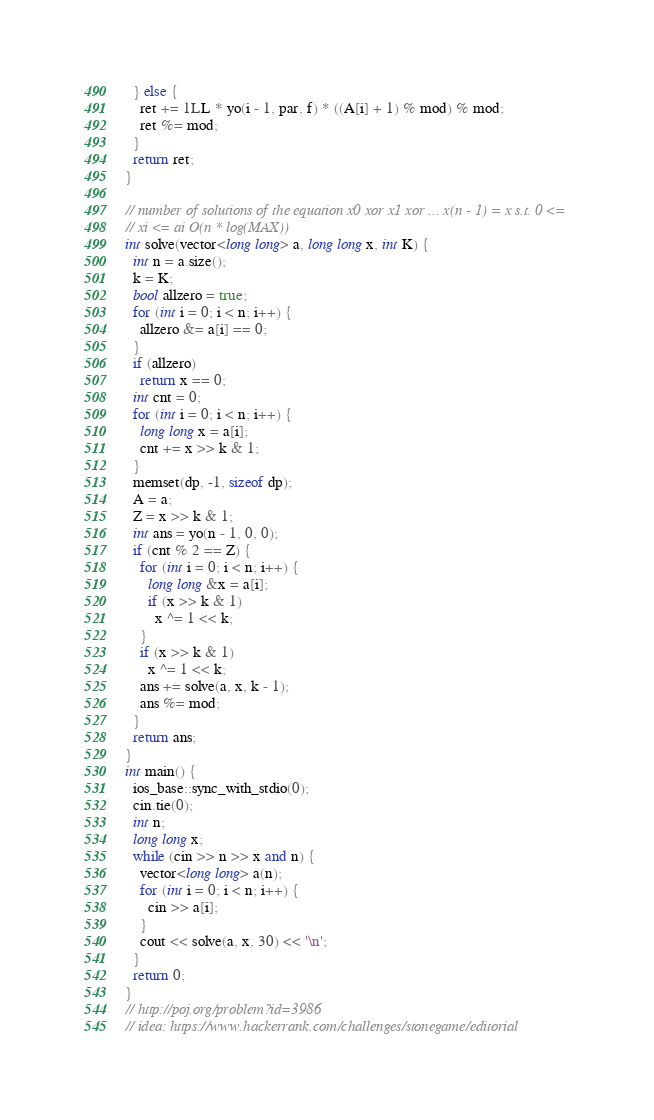<code> <loc_0><loc_0><loc_500><loc_500><_C++_>  } else {
    ret += 1LL * yo(i - 1, par, f) * ((A[i] + 1) % mod) % mod;
    ret %= mod;
  }
  return ret;
}

// number of solutions of the equation x0 xor x1 xor ... x(n - 1) = x s.t. 0 <=
// xi <= ai O(n * log(MAX))
int solve(vector<long long> a, long long x, int K) {
  int n = a.size();
  k = K;
  bool allzero = true;
  for (int i = 0; i < n; i++) {
    allzero &= a[i] == 0;
  }
  if (allzero)
    return x == 0;
  int cnt = 0;
  for (int i = 0; i < n; i++) {
    long long x = a[i];
    cnt += x >> k & 1;
  }
  memset(dp, -1, sizeof dp);
  A = a;
  Z = x >> k & 1;
  int ans = yo(n - 1, 0, 0);
  if (cnt % 2 == Z) {
    for (int i = 0; i < n; i++) {
      long long &x = a[i];
      if (x >> k & 1)
        x ^= 1 << k;
    }
    if (x >> k & 1)
      x ^= 1 << k;
    ans += solve(a, x, k - 1);
    ans %= mod;
  }
  return ans;
}
int main() {
  ios_base::sync_with_stdio(0);
  cin.tie(0);
  int n;
  long long x;
  while (cin >> n >> x and n) {
    vector<long long> a(n);
    for (int i = 0; i < n; i++) {
      cin >> a[i];
    }
    cout << solve(a, x, 30) << '\n';
  }
  return 0;
}
// http://poj.org/problem?id=3986
// idea: https://www.hackerrank.com/challenges/stonegame/editorial
</code> 